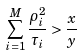Convert formula to latex. <formula><loc_0><loc_0><loc_500><loc_500>\sum _ { i = 1 } ^ { M } \frac { \rho _ { i } ^ { 2 } } { \tau _ { i } } > \frac { x } { y }</formula> 